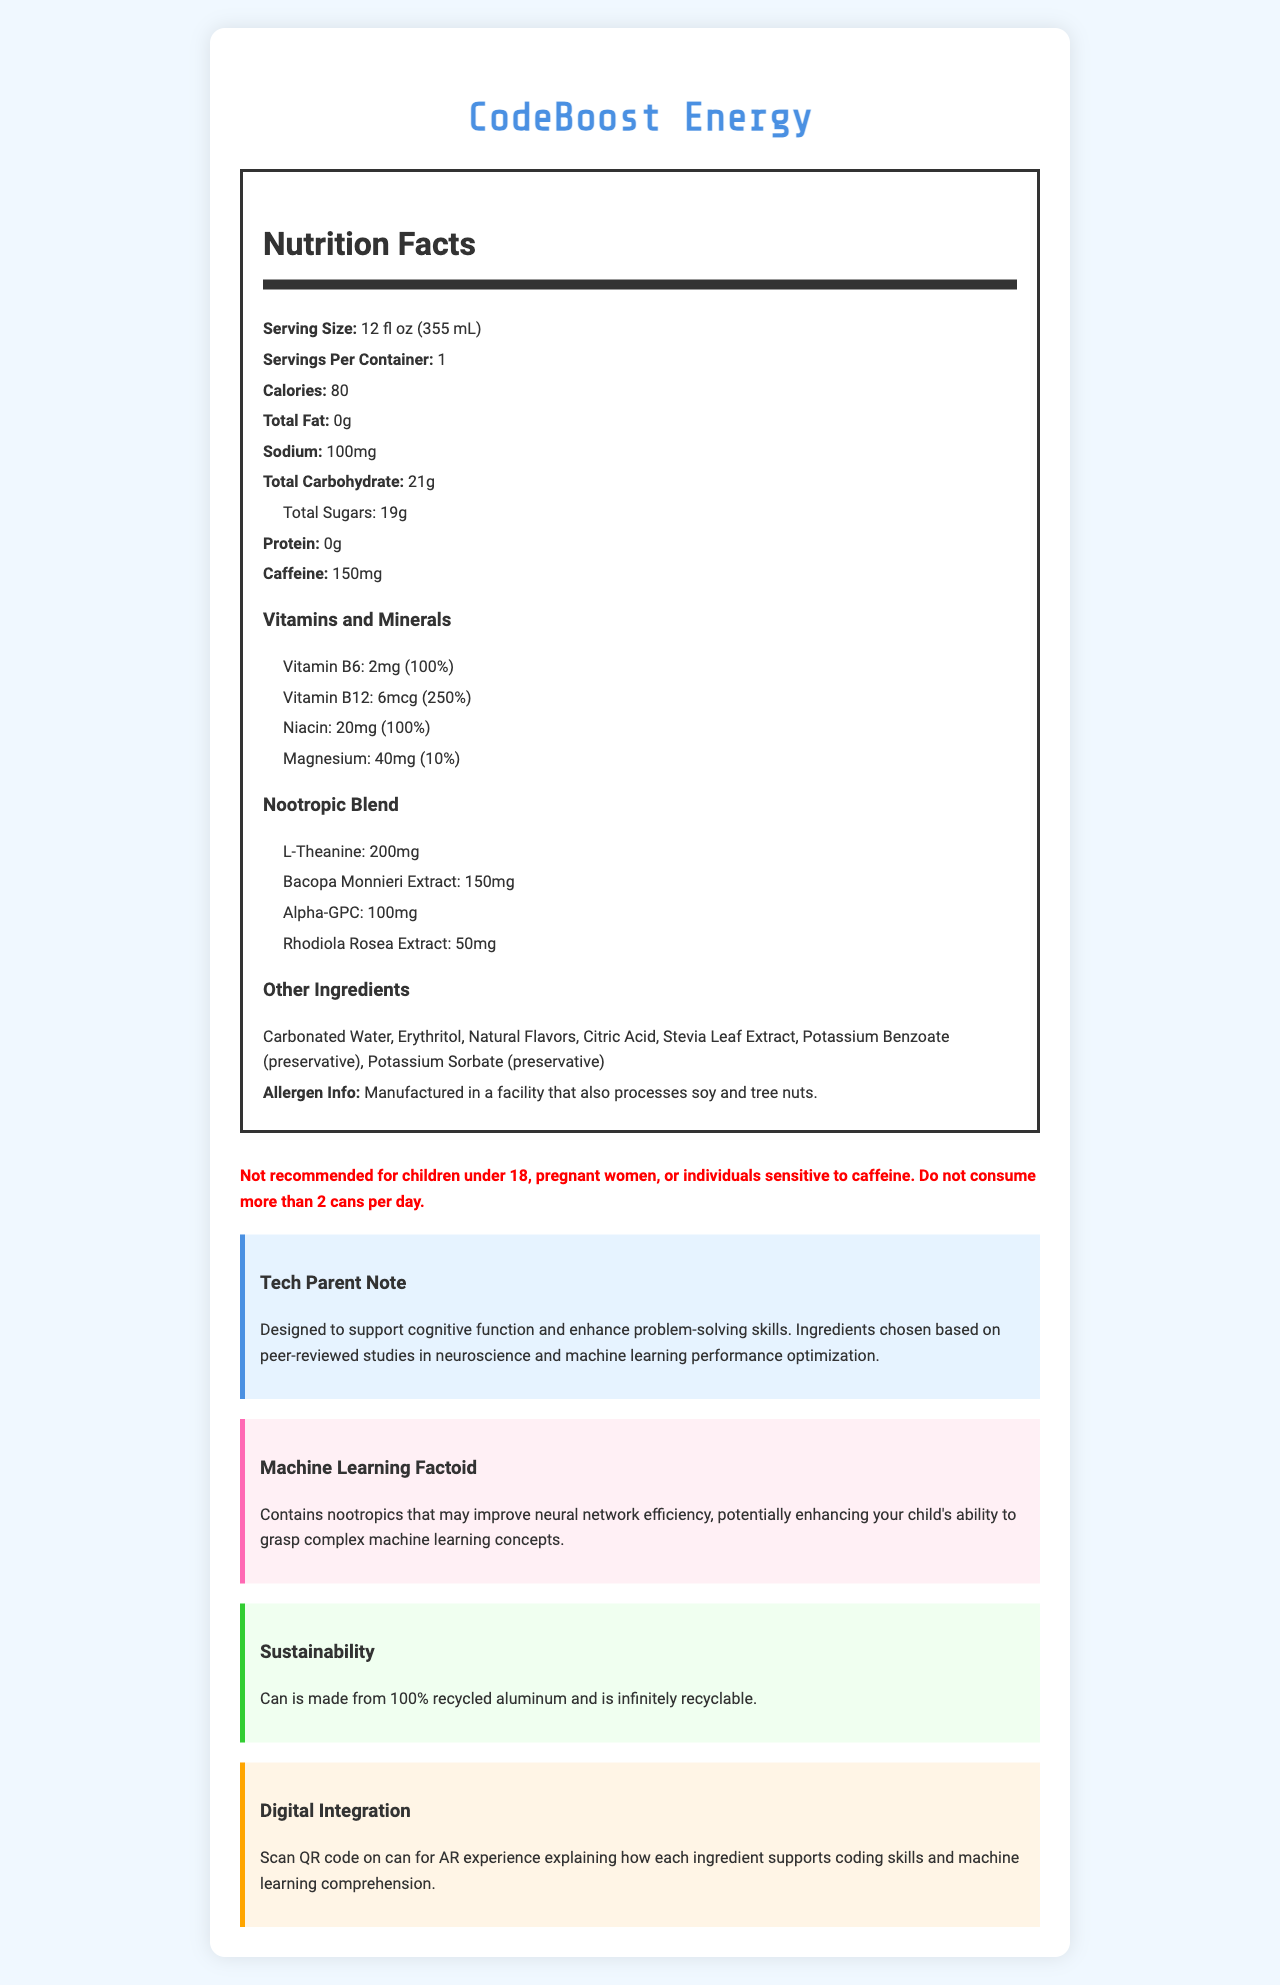what is the serving size for CodeBoost Energy? The document specifies that the serving size for CodeBoost Energy is 12 fluid ounces, which is equivalent to 355 milliliters.
Answer: 12 fl oz (355 mL) how much caffeine does one can of CodeBoost Energy contain? The document mentions that one can contains 150 milligrams of caffeine.
Answer: 150mg which vitamins are included in the CodeBoost Energy drink? The document lists the included vitamins and minerals as Vitamin B6, Vitamin B12, Niacin, and Magnesium.
Answer: Vitamin B6, Vitamin B12, Niacin, Magnesium what is the total carbohydrate content per serving? The document states that the total carbohydrate content per serving is 21 grams.
Answer: 21g what are the nootropic ingredients and their amounts? The document lists the nootropic ingredients and their amounts as follows: L-Theanine (200mg), Bacopa Monnieri Extract (150mg), Alpha-GPC (100mg), Rhodiola Rosea Extract (50mg).
Answer: L-Theanine: 200mg, Bacopa Monnieri Extract: 150mg, Alpha-GPC: 100mg, Rhodiola Rosea Extract: 50mg how many calories are there in one serving of CodeBoost Energy? The document indicates that there are 80 calories per serving.
Answer: 80 calories which ingredient is used as a preservative in CodeBoost Energy? A. Erythritol B. Citric Acid C. Potassium Benzoate The document mentions Potassium Benzoate as a preservative in the list of other ingredients.
Answer: C what is the recommended maximum daily consumption of CodeBoost Energy? A. 1 can B. 2 cans C. 3 cans D. 4 cans The document warns not to consume more than 2 cans per day.
Answer: B is the can of CodeBoost Energy recyclable? The document states that the can is made from 100% recycled aluminum and is infinitely recyclable.
Answer: Yes is CodeBoost Energy recommended for children under 18? The warning section of the document clearly states that it is not recommended for children under 18.
Answer: No summarize the main idea of the document. The document primarily details the nutritional and functional benefits of CodeBoost Energy, as well as safety warnings, sustainability practices, and its potential to support cognitive functions relevant to coding and machine learning.
Answer: CodeBoost Energy is an energy drink designed to enhance coding and problem-solving skills through a blend of caffeine, nootropic ingredients, and essential vitamins and minerals. The drink is low-calorie, contains no fat or protein, and provides cognitive benefits based on neuroscience and machine learning research. The can is made from sustainable materials and includes a digital integration feature. what research supports the cognitive benefits of CodeBoost Energy? The document mentions that the ingredients were chosen based on peer-reviewed studies, but it does not provide specific details about the research or the studies referenced.
Answer: Not enough information 